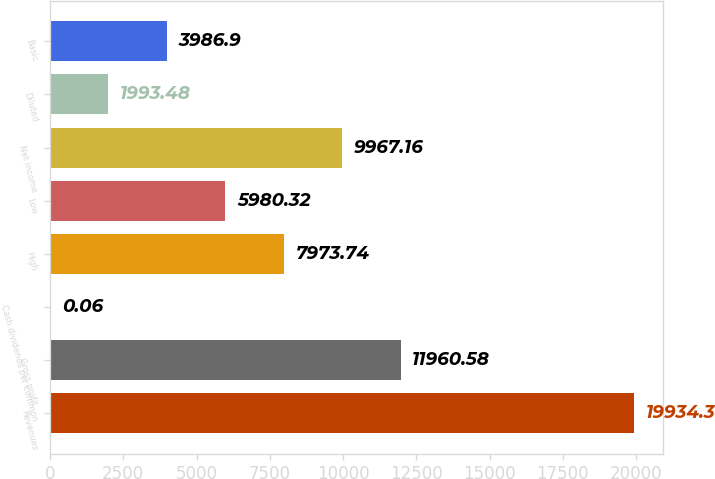<chart> <loc_0><loc_0><loc_500><loc_500><bar_chart><fcel>Revenues<fcel>Gross profit<fcel>Cash dividends per common<fcel>High<fcel>Low<fcel>Net income<fcel>Diluted<fcel>Basic<nl><fcel>19934.3<fcel>11960.6<fcel>0.06<fcel>7973.74<fcel>5980.32<fcel>9967.16<fcel>1993.48<fcel>3986.9<nl></chart> 